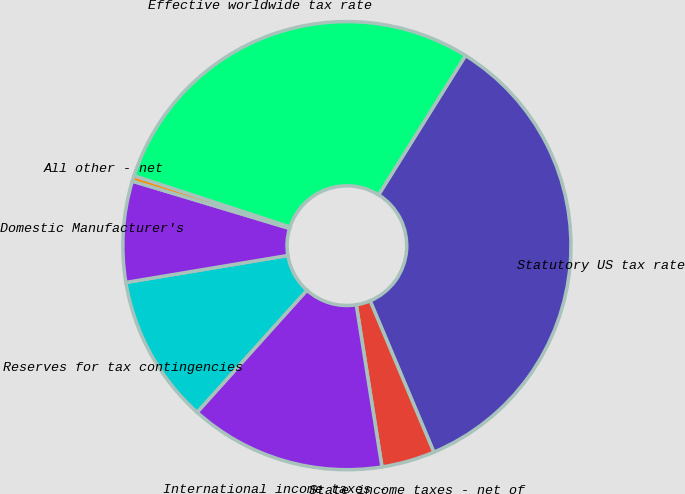<chart> <loc_0><loc_0><loc_500><loc_500><pie_chart><fcel>Statutory US tax rate<fcel>State income taxes - net of<fcel>International income taxes -<fcel>Reserves for tax contingencies<fcel>Domestic Manufacturer's<fcel>All other - net<fcel>Effective worldwide tax rate<nl><fcel>34.79%<fcel>3.84%<fcel>14.16%<fcel>10.72%<fcel>7.28%<fcel>0.4%<fcel>28.83%<nl></chart> 